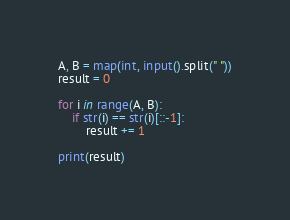<code> <loc_0><loc_0><loc_500><loc_500><_Python_>A, B = map(int, input().split(" "))
result = 0

for i in range(A, B):
    if str(i) == str(i)[::-1]:
        result += 1

print(result)
</code> 